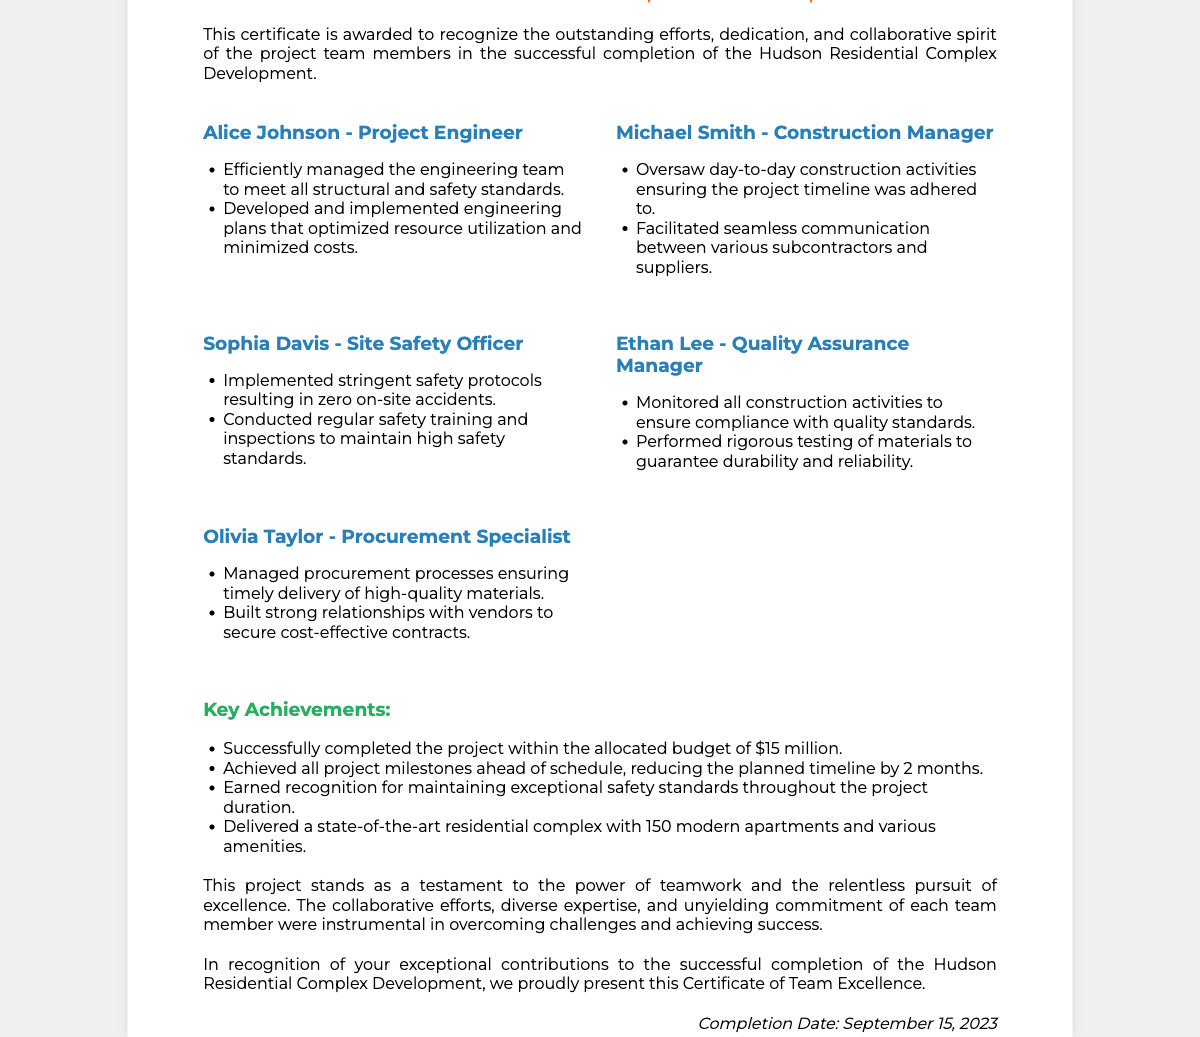What is the title of the project? The title is prominently displayed in the document and reflects the main project undertaken by the team.
Answer: Hudson Residential Complex Development Who is the Project Engineer? This question asks for the specific person responsible for engineering tasks within the project.
Answer: Alice Johnson What date was the project completed? The completion date of the project is explicitly mentioned at the end of the document.
Answer: September 15, 2023 How many apartments were delivered in the project? This question pertains to the project's key achievements, specifically the number of units completed.
Answer: 150 modern apartments What was the allocated budget for the project? This question inquires about the financial aspect of the project, which is one of the key achievements listed.
Answer: $15 million Which team member was responsible for safety? This explores the roles of team members and identifies the specific person in charge of safety measures.
Answer: Sophia Davis What is recognized as a key achievement of the project? This looks for specific accomplishments listed in the document relating to the successful outcomes of the project.
Answer: Achieved all project milestones ahead of schedule What does this certificate acknowledge? This question reflects on the main purpose of the certificate as stated in the introductory paragraph.
Answer: Outstanding efforts, dedication, and collaborative spirit Who managed the procurement processes? This question helps identify the person responsible for obtaining project materials and supplies.
Answer: Olivia Taylor What was the impact of teamwork on the project? This question asks for a summary of the overall contribution of the team as mentioned in the document.
Answer: Instrumental in overcoming challenges and achieving success 